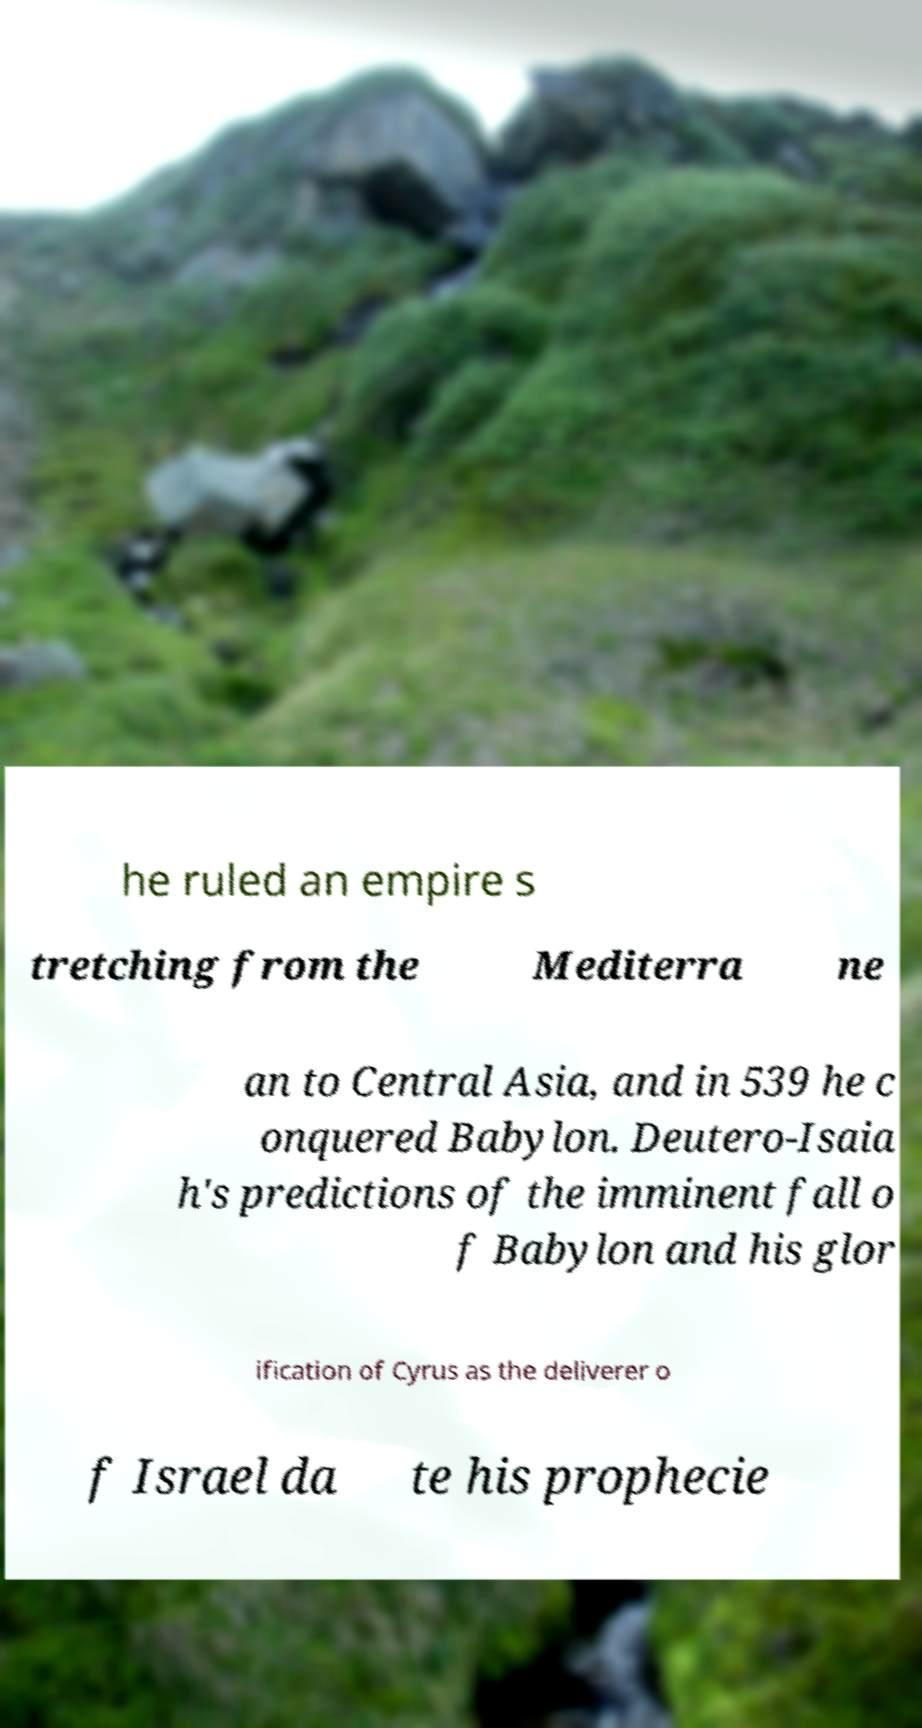There's text embedded in this image that I need extracted. Can you transcribe it verbatim? he ruled an empire s tretching from the Mediterra ne an to Central Asia, and in 539 he c onquered Babylon. Deutero-Isaia h's predictions of the imminent fall o f Babylon and his glor ification of Cyrus as the deliverer o f Israel da te his prophecie 